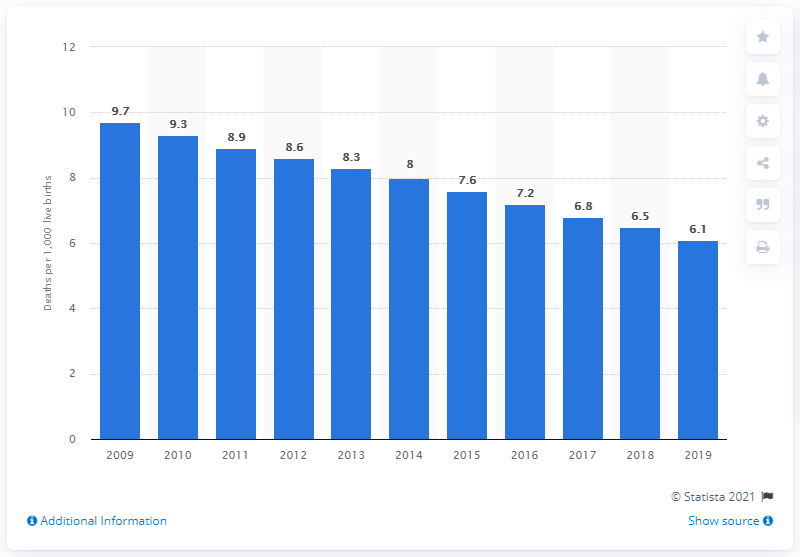Point out several critical features in this image. In 2019, the infant mortality rate in Uruguay was 6.1 deaths per 1,000 live births. 